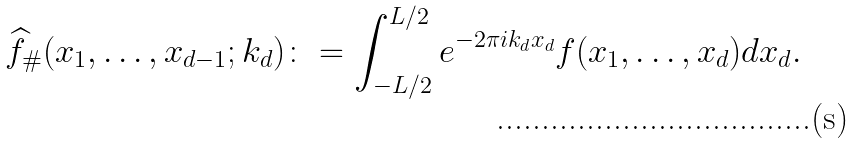Convert formula to latex. <formula><loc_0><loc_0><loc_500><loc_500>\widehat { f } _ { \# } ( x _ { 1 } , \dots , x _ { d - 1 } ; k _ { d } ) \colon = \int _ { - L / 2 } ^ { L / 2 } e ^ { - 2 \pi i k _ { d } x _ { d } } f ( x _ { 1 } , \dots , x _ { d } ) d x _ { d } .</formula> 